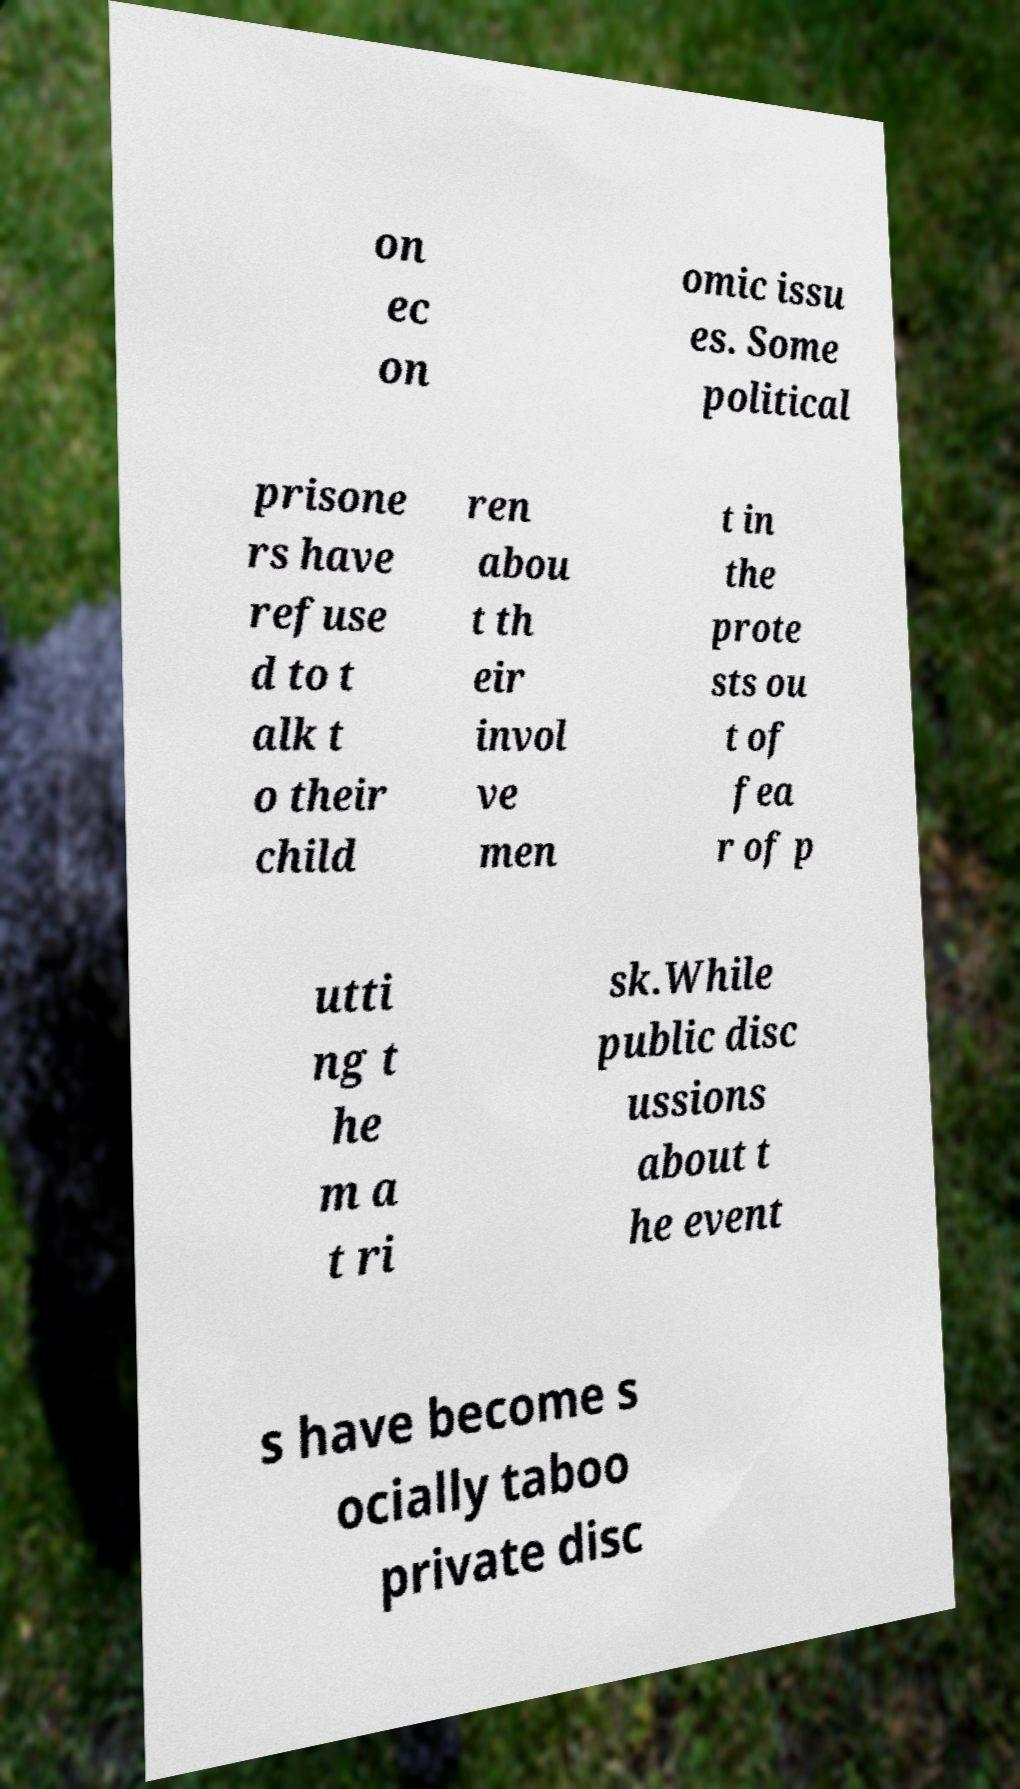I need the written content from this picture converted into text. Can you do that? on ec on omic issu es. Some political prisone rs have refuse d to t alk t o their child ren abou t th eir invol ve men t in the prote sts ou t of fea r of p utti ng t he m a t ri sk.While public disc ussions about t he event s have become s ocially taboo private disc 